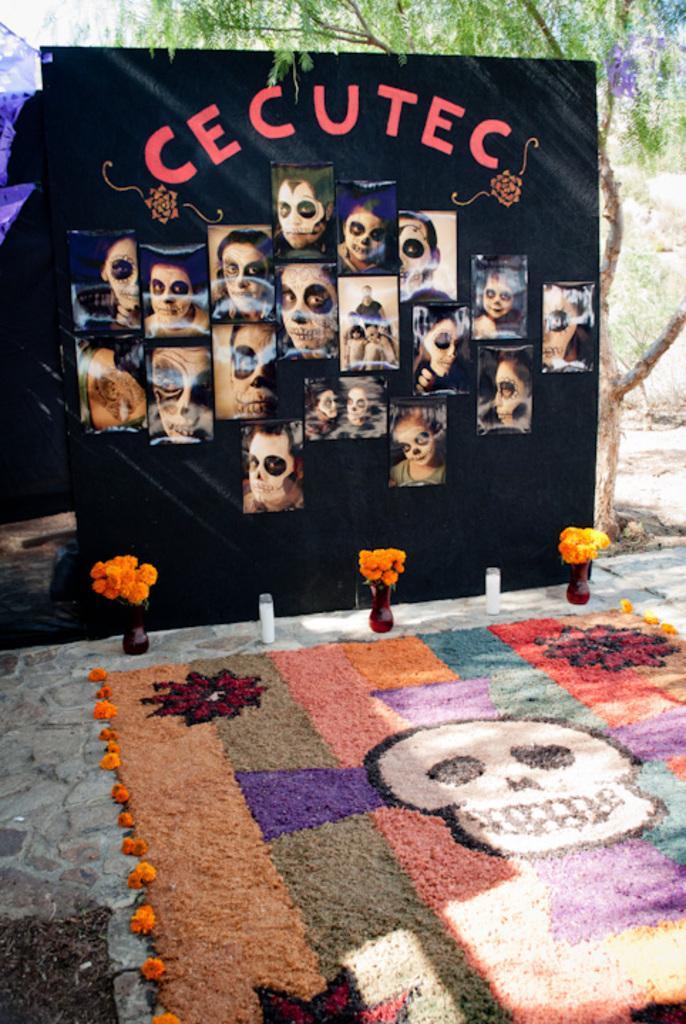In one or two sentences, can you explain what this image depicts? In this image there is a banner on the floor. There are pictures and text on the banner. Behind the banner there are trees. In front of the banner there are flower vases. At bottom there is decoration on the floor. 